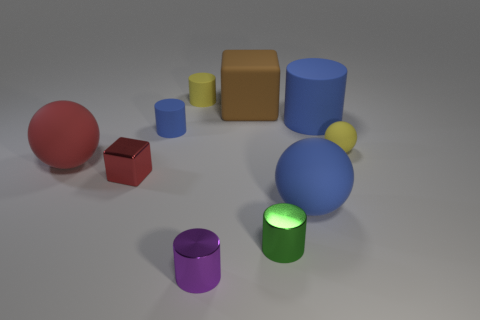What size is the other blue matte thing that is the same shape as the small blue rubber object?
Your response must be concise. Large. What number of large matte blocks are behind the big brown object in front of the yellow thing left of the big brown rubber object?
Provide a short and direct response. 0. What is the size of the other cylinder that is the same color as the large matte cylinder?
Give a very brief answer. Small. What shape is the tiny green object?
Offer a terse response. Cylinder. How many small green cylinders have the same material as the big cube?
Make the answer very short. 0. The other cylinder that is the same material as the green cylinder is what color?
Your response must be concise. Purple. There is a yellow ball; is it the same size as the cylinder that is on the right side of the green shiny cylinder?
Ensure brevity in your answer.  No. There is a blue cylinder that is to the right of the big matte object that is behind the blue cylinder on the right side of the tiny blue object; what is its material?
Your answer should be compact. Rubber. What number of objects are either big blue balls or metal things?
Make the answer very short. 4. There is a big object in front of the big red ball; is its color the same as the matte cylinder on the right side of the tiny green metallic cylinder?
Your response must be concise. Yes. 